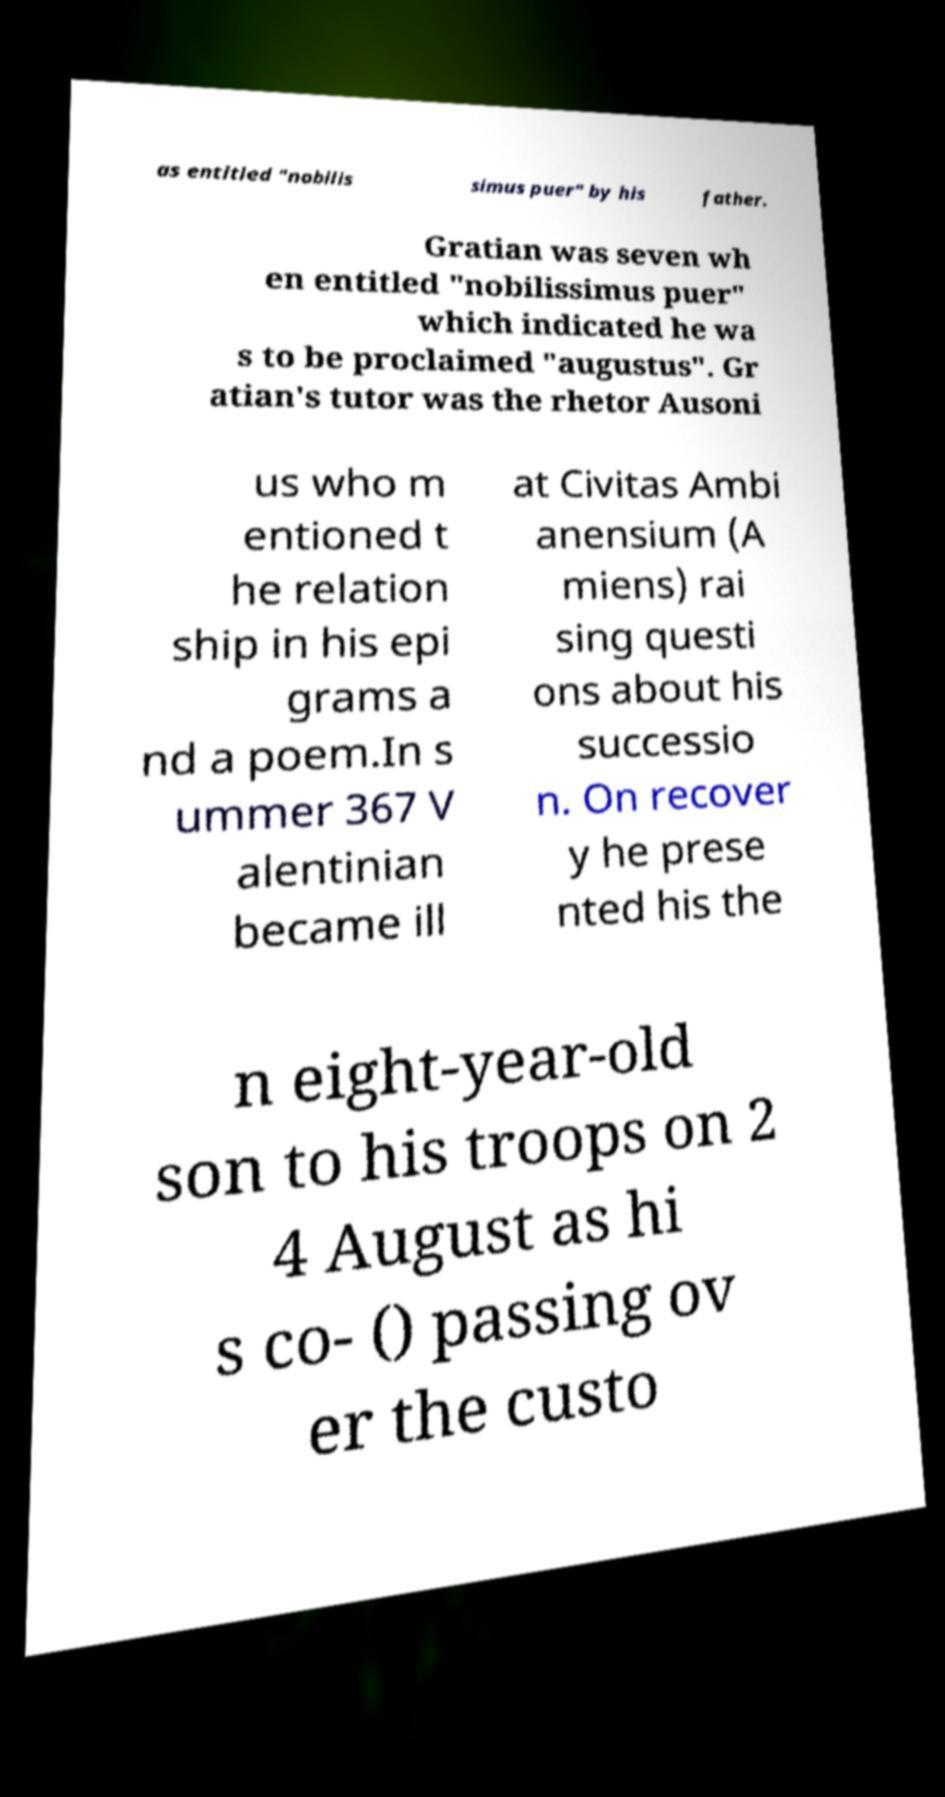Please identify and transcribe the text found in this image. as entitled "nobilis simus puer" by his father. Gratian was seven wh en entitled "nobilissimus puer" which indicated he wa s to be proclaimed "augustus". Gr atian's tutor was the rhetor Ausoni us who m entioned t he relation ship in his epi grams a nd a poem.In s ummer 367 V alentinian became ill at Civitas Ambi anensium (A miens) rai sing questi ons about his successio n. On recover y he prese nted his the n eight-year-old son to his troops on 2 4 August as hi s co- () passing ov er the custo 